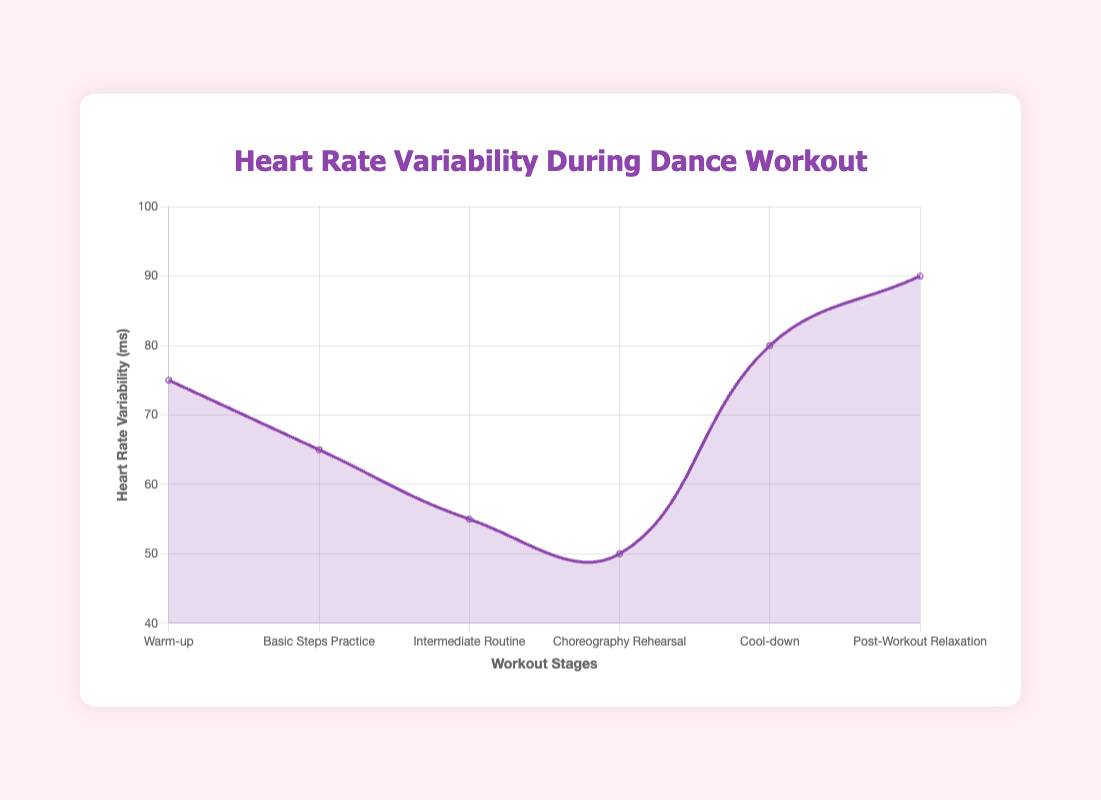What is the lowest mean HRV value observed in different stages of the dance workout? The figure shows the mean HRV values at different stages. The lowest value corresponds to the Choreography Rehearsal stage, with a mean HRV of 50 ms.
Answer: 50 ms How much higher is the mean HRV value during Cool-down compared to the Intermediate Routine? The mean HRV during Cool-down is 80 ms, and during the Intermediate Routine, it is 55 ms. The difference between them is 80 - 55 = 25 ms.
Answer: 25 ms What stage has the highest increase in mean HRV from the preceding stage? The figure reveals that the mean HRV increases significantly between the Choreography Rehearsal and Cool-down stages, from 50 ms to 80 ms. This increase is 30 ms, which is the highest among all transitions.
Answer: Cool-down Which stage has the smallest standard deviation of mean HRV? The smallest standard deviation in mean HRV is observed during the Post-Workout Relaxation stage, with a standard deviation of 5 ms.
Answer: Post-Workout Relaxation Rank the stages in descending order of their mean HRV values. The mean HRV values in order from highest to lowest are Post-Workout Relaxation (90 ms), Cool-down (80 ms), Warm-up (75 ms), Basic Steps Practice (65 ms), Intermediate Routine (55 ms), and Choreography Rehearsal (50 ms).
Answer: Post-Workout Relaxation, Cool-down, Warm-up, Basic Steps Practice, Intermediate Routine, Choreography Rehearsal What is the total duration of all stages combined in the dance workout? Summing the durations of all stages: 10 + 15 + 20 + 30 + 10 + 15 = 100 minutes.
Answer: 100 minutes Compare the mean HRV values between Warm-up and Basic Steps Practice stages. The mean HRV during Warm-up is 75 ms, and during Basic Steps Practice, it is 65 ms. Thus, the HRV value during Warm-up is 75 - 65 = 10 ms higher than during Basic Steps Practice.
Answer: Warm-up is 10 ms higher Which stage represents a significant increase in HRV after a period of high intensity? After the high-intensity Choreography Rehearsal stage (50 ms), the HRV significantly increases to 80 ms during the Cool-down stage.
Answer: Cool-down 